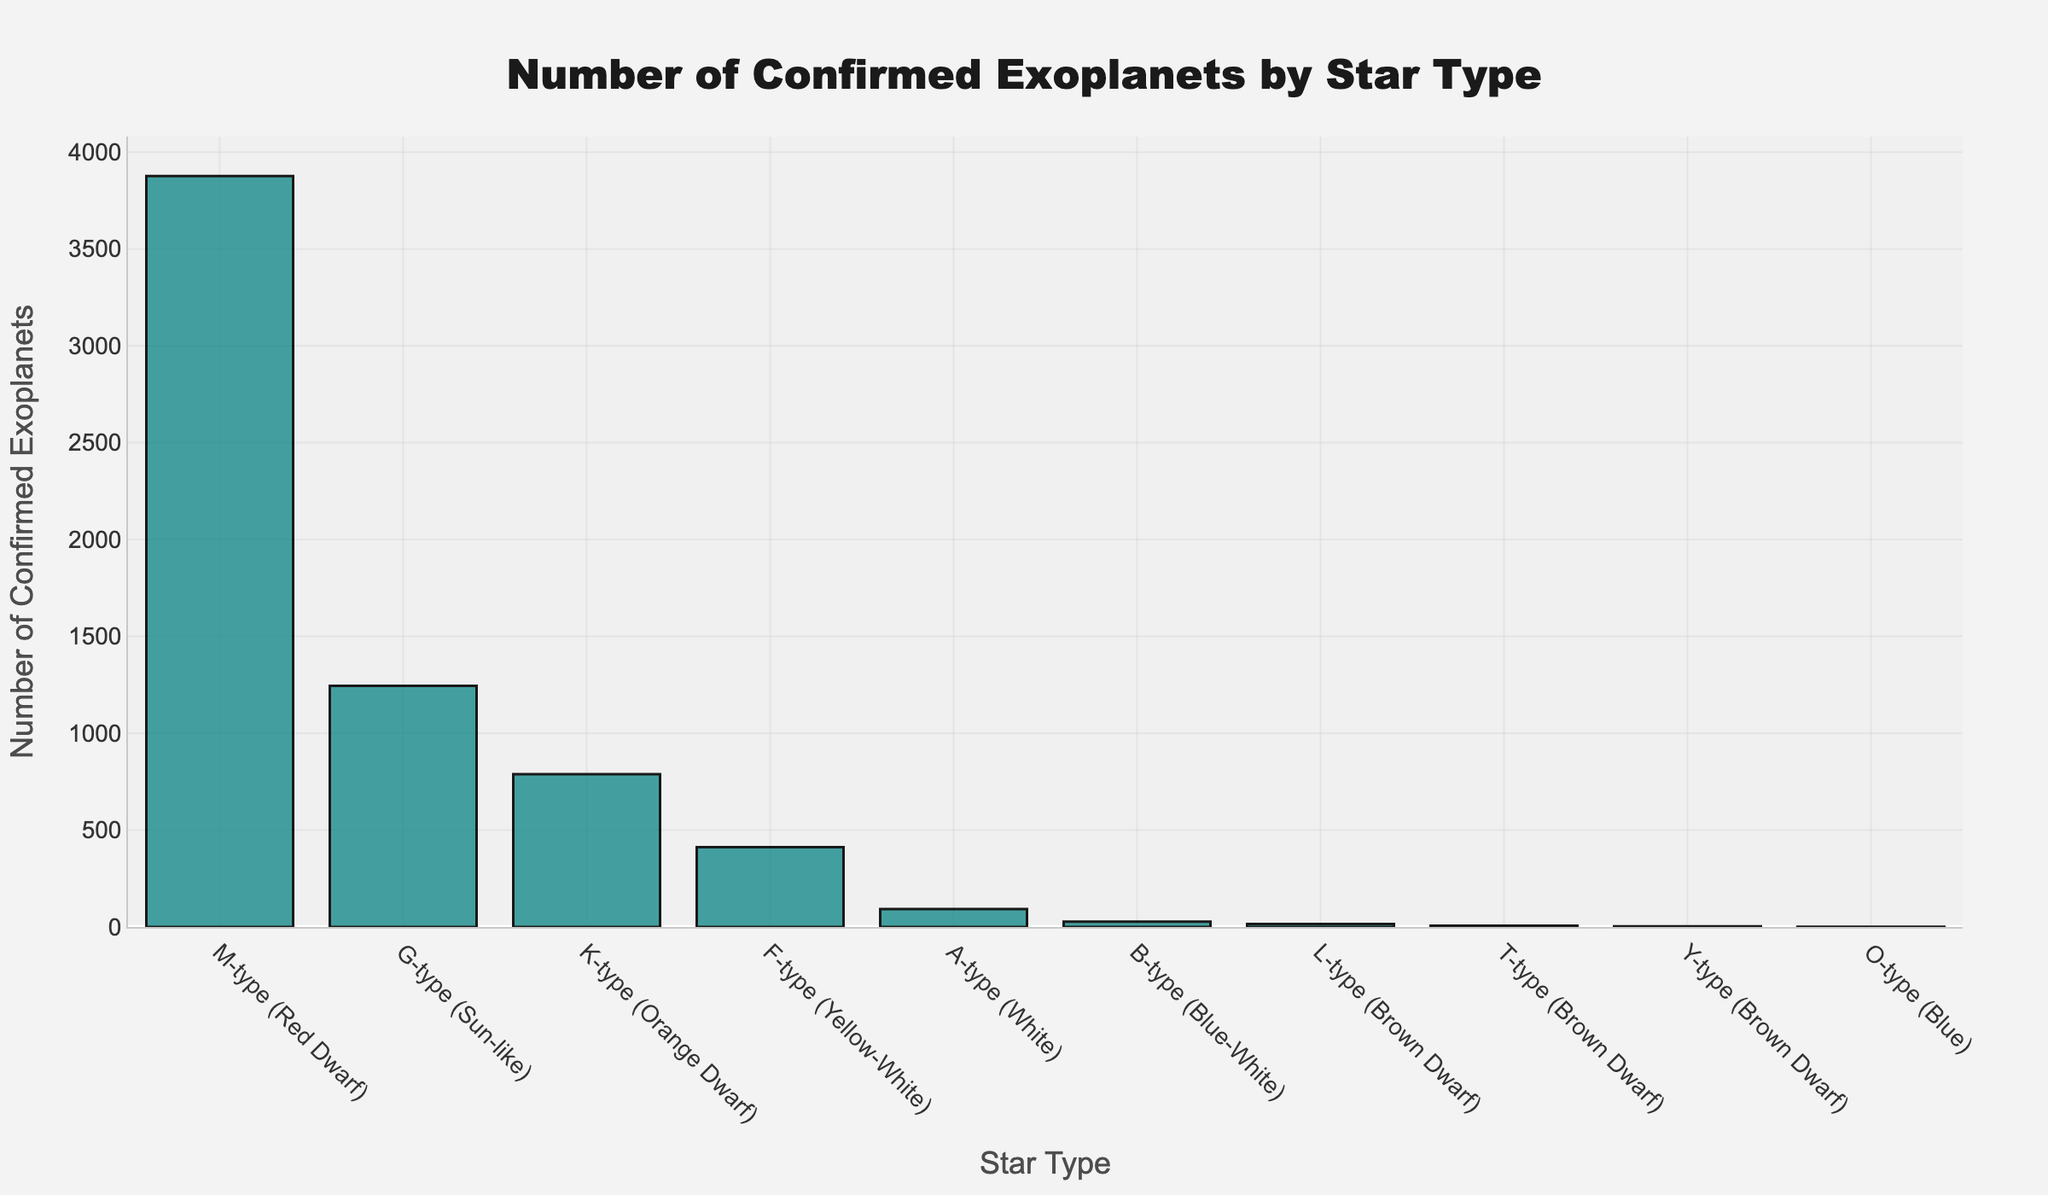How many confirmed exoplanets are in total for the top three star types? First, identify the top three star types based on the number of confirmed exoplanets: M-type (3876), G-type (1245), and K-type (789). Add their counts together: 3876 + 1245 + 789 = 5910.
Answer: 5910 Which star type has the fewest confirmed exoplanets, and how many does it have? The star type with the fewest confirmed exoplanets is O-type, which has only 1 confirmed exoplanet.
Answer: O-type, 1 What is the difference in the number of confirmed exoplanets between M-type stars and G-type stars? M-type stars have 3876 confirmed exoplanets, and G-type stars have 1245. Subtract the count for G-type from M-type: 3876 - 1245 = 2631.
Answer: 2631 Which star types have fewer than 100 confirmed exoplanets? Identify star types with confirmed exoplanets less than 100: A-type (92), B-type (28), L-type (15), T-type (7), Y-type (3), O-type (1).
Answer: A-type, B-type, L-type, T-type, Y-type, O-type What is the sum of confirmed exoplanets for all star types classified as brown dwarfs? Sum the confirmed exoplanets for L-type (15), T-type (7), and Y-type (3) stars: 15 + 7 + 3 = 25.
Answer: 25 How many more confirmed exoplanets do G-type stars have compared to F-type stars? G-type stars have 1245 confirmed exoplanets, and F-type stars have 412. Subtract the F-type from the G-type: 1245 - 412 = 833.
Answer: 833 What percentage of the total confirmed exoplanets does the M-type star category represent? First, find the total number of confirmed exoplanets: 3876 (M-type) + 1245 (G-type) + 789 (K-type) + 412 (F-type) + 92 (A-type) + 28 (B-type) + 15 (L-type) + 7 (T-type) + 3 (Y-type) + 1 (O-type) = 6468. Now, calculate the percentage for M-type: (3876 / 6468) * 100 ≈ 59.92%.
Answer: 59.92% If the confirmed exoplanets for K-type stars doubled, would they surpass the number of confirmed exoplanets for G-type stars? Doubling the K-type confirmed exoplanets gives 789 * 2 = 1578. Since 1578 is greater than 1245 (G-type), K-type would surpass G-type in confirmed exoplanets.
Answer: Yes 